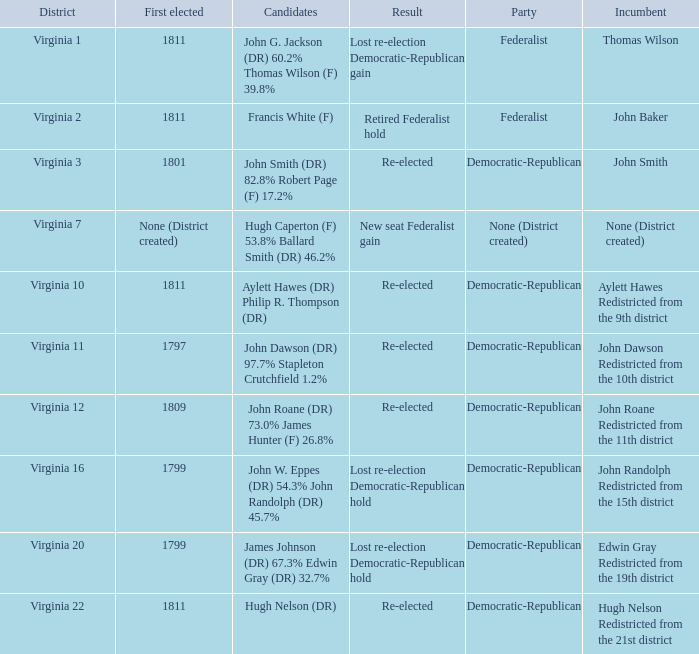Name the party for  john randolph redistricted from the 15th district Democratic-Republican. Would you be able to parse every entry in this table? {'header': ['District', 'First elected', 'Candidates', 'Result', 'Party', 'Incumbent'], 'rows': [['Virginia 1', '1811', 'John G. Jackson (DR) 60.2% Thomas Wilson (F) 39.8%', 'Lost re-election Democratic-Republican gain', 'Federalist', 'Thomas Wilson'], ['Virginia 2', '1811', 'Francis White (F)', 'Retired Federalist hold', 'Federalist', 'John Baker'], ['Virginia 3', '1801', 'John Smith (DR) 82.8% Robert Page (F) 17.2%', 'Re-elected', 'Democratic-Republican', 'John Smith'], ['Virginia 7', 'None (District created)', 'Hugh Caperton (F) 53.8% Ballard Smith (DR) 46.2%', 'New seat Federalist gain', 'None (District created)', 'None (District created)'], ['Virginia 10', '1811', 'Aylett Hawes (DR) Philip R. Thompson (DR)', 'Re-elected', 'Democratic-Republican', 'Aylett Hawes Redistricted from the 9th district'], ['Virginia 11', '1797', 'John Dawson (DR) 97.7% Stapleton Crutchfield 1.2%', 'Re-elected', 'Democratic-Republican', 'John Dawson Redistricted from the 10th district'], ['Virginia 12', '1809', 'John Roane (DR) 73.0% James Hunter (F) 26.8%', 'Re-elected', 'Democratic-Republican', 'John Roane Redistricted from the 11th district'], ['Virginia 16', '1799', 'John W. Eppes (DR) 54.3% John Randolph (DR) 45.7%', 'Lost re-election Democratic-Republican hold', 'Democratic-Republican', 'John Randolph Redistricted from the 15th district'], ['Virginia 20', '1799', 'James Johnson (DR) 67.3% Edwin Gray (DR) 32.7%', 'Lost re-election Democratic-Republican hold', 'Democratic-Republican', 'Edwin Gray Redistricted from the 19th district'], ['Virginia 22', '1811', 'Hugh Nelson (DR)', 'Re-elected', 'Democratic-Republican', 'Hugh Nelson Redistricted from the 21st district']]} 